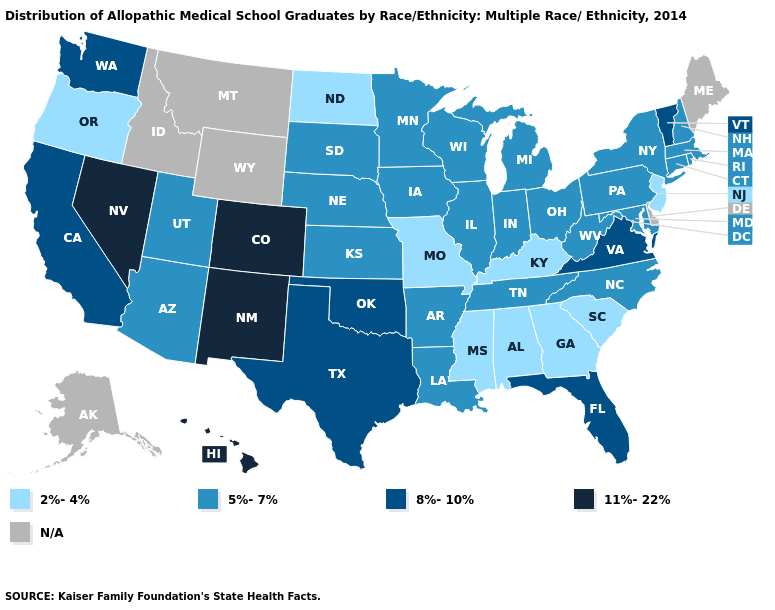What is the value of West Virginia?
Keep it brief. 5%-7%. What is the value of Wisconsin?
Write a very short answer. 5%-7%. What is the value of Rhode Island?
Answer briefly. 5%-7%. What is the lowest value in the USA?
Give a very brief answer. 2%-4%. Which states have the lowest value in the West?
Keep it brief. Oregon. What is the value of Utah?
Be succinct. 5%-7%. Name the states that have a value in the range N/A?
Give a very brief answer. Alaska, Delaware, Idaho, Maine, Montana, Wyoming. Which states have the highest value in the USA?
Quick response, please. Colorado, Hawaii, Nevada, New Mexico. What is the highest value in the USA?
Keep it brief. 11%-22%. What is the lowest value in the West?
Write a very short answer. 2%-4%. Name the states that have a value in the range 11%-22%?
Be succinct. Colorado, Hawaii, Nevada, New Mexico. Is the legend a continuous bar?
Answer briefly. No. Name the states that have a value in the range 8%-10%?
Give a very brief answer. California, Florida, Oklahoma, Texas, Vermont, Virginia, Washington. What is the value of Hawaii?
Concise answer only. 11%-22%. 